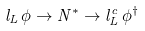Convert formula to latex. <formula><loc_0><loc_0><loc_500><loc_500>l _ { L } \, \phi \rightarrow N ^ { * } \rightarrow l ^ { c } _ { L } \, \phi ^ { \dagger }</formula> 